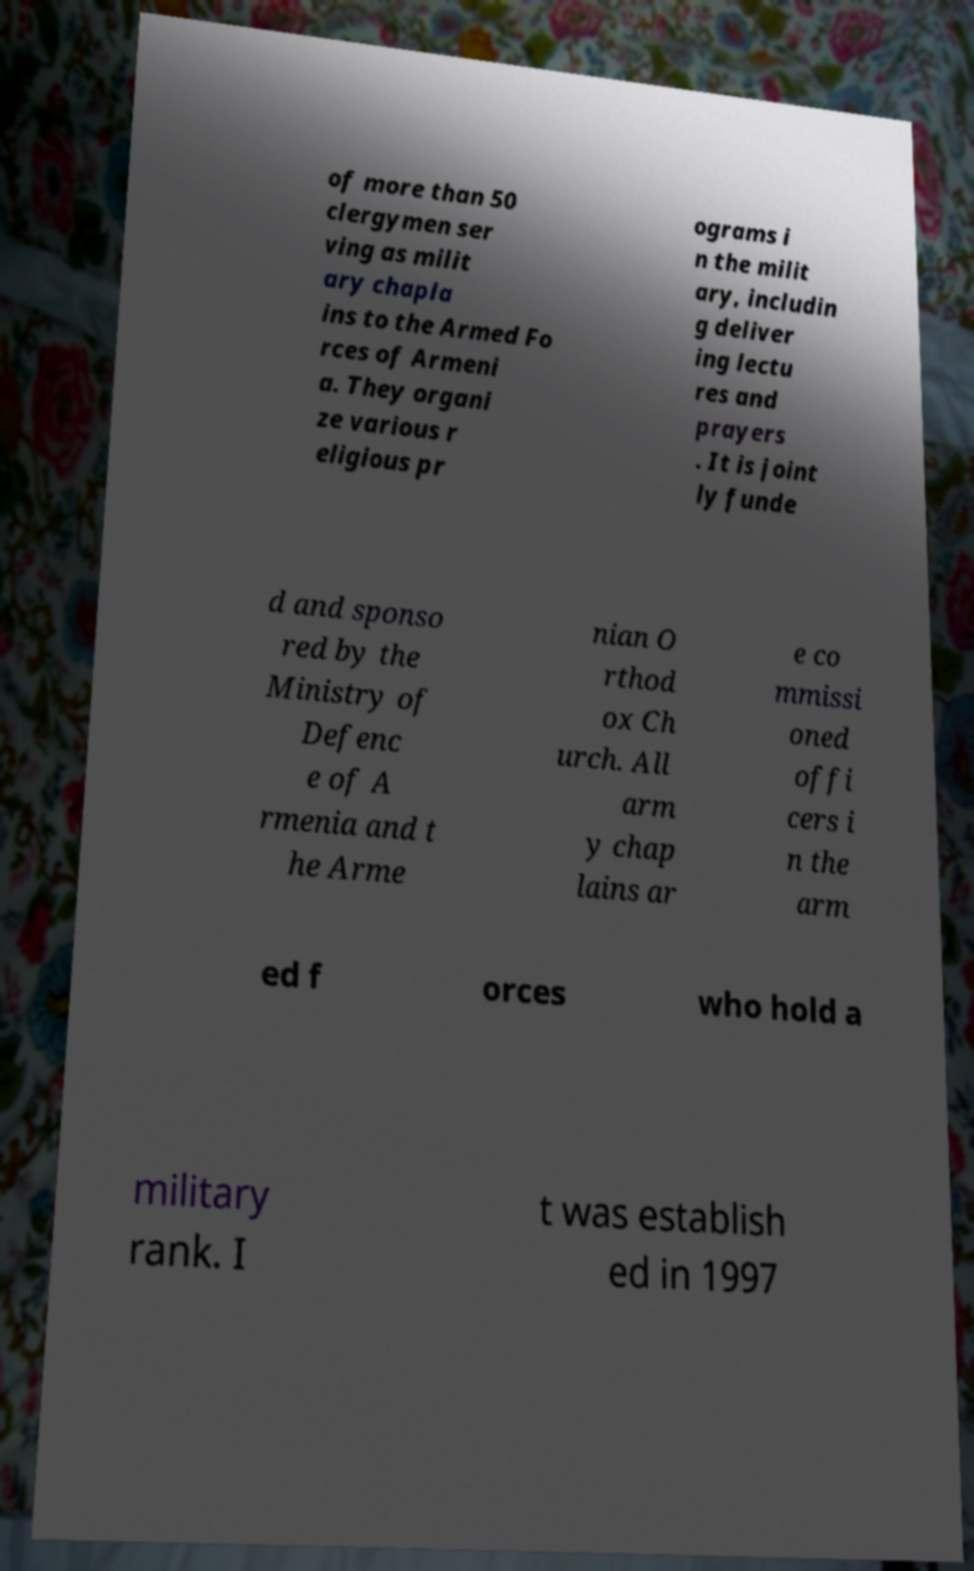Can you accurately transcribe the text from the provided image for me? of more than 50 clergymen ser ving as milit ary chapla ins to the Armed Fo rces of Armeni a. They organi ze various r eligious pr ograms i n the milit ary, includin g deliver ing lectu res and prayers . It is joint ly funde d and sponso red by the Ministry of Defenc e of A rmenia and t he Arme nian O rthod ox Ch urch. All arm y chap lains ar e co mmissi oned offi cers i n the arm ed f orces who hold a military rank. I t was establish ed in 1997 